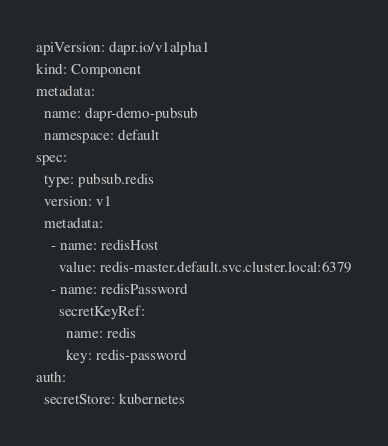<code> <loc_0><loc_0><loc_500><loc_500><_YAML_>apiVersion: dapr.io/v1alpha1
kind: Component
metadata:
  name: dapr-demo-pubsub
  namespace: default
spec:
  type: pubsub.redis
  version: v1
  metadata:
    - name: redisHost
      value: redis-master.default.svc.cluster.local:6379
    - name: redisPassword
      secretKeyRef:
        name: redis
        key: redis-password
auth:
  secretStore: kubernetes
</code> 